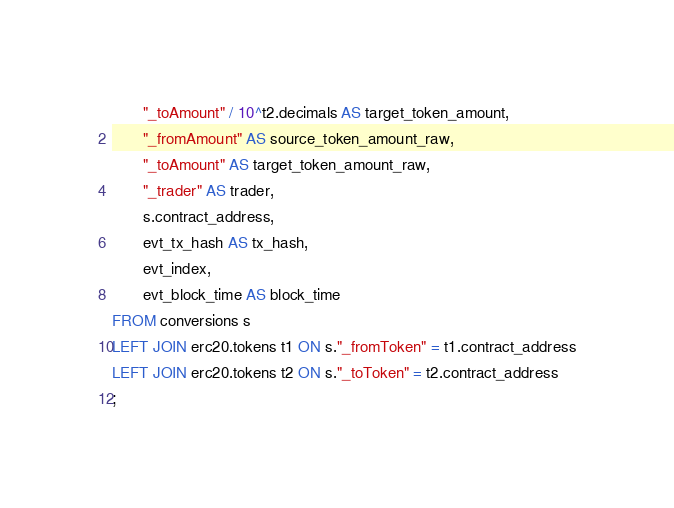<code> <loc_0><loc_0><loc_500><loc_500><_SQL_>       "_toAmount" / 10^t2.decimals AS target_token_amount,
       "_fromAmount" AS source_token_amount_raw,
       "_toAmount" AS target_token_amount_raw,
       "_trader" AS trader,
       s.contract_address,
       evt_tx_hash AS tx_hash,
       evt_index,
       evt_block_time AS block_time
FROM conversions s
LEFT JOIN erc20.tokens t1 ON s."_fromToken" = t1.contract_address
LEFT JOIN erc20.tokens t2 ON s."_toToken" = t2.contract_address
;
</code> 